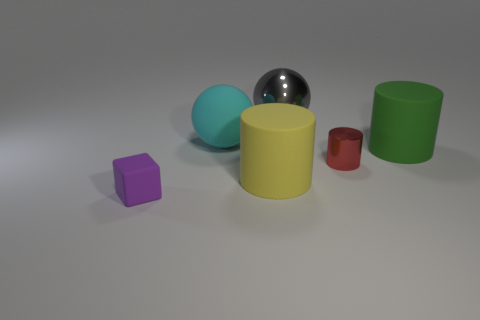Subtract all metal cylinders. How many cylinders are left? 2 Add 1 large purple matte balls. How many objects exist? 7 Subtract all yellow cylinders. How many cylinders are left? 2 Subtract all cubes. How many objects are left? 5 Add 3 tiny purple matte things. How many tiny purple matte things are left? 4 Add 4 small red shiny cylinders. How many small red shiny cylinders exist? 5 Subtract 0 yellow blocks. How many objects are left? 6 Subtract all cyan balls. Subtract all purple cubes. How many balls are left? 1 Subtract all cyan things. Subtract all large green matte objects. How many objects are left? 4 